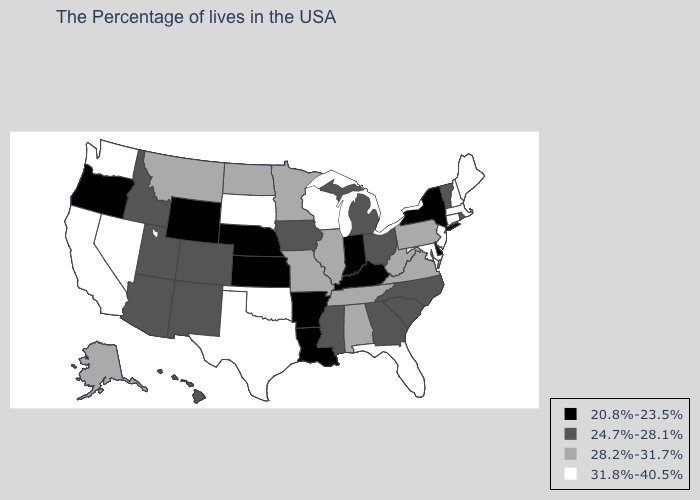Name the states that have a value in the range 31.8%-40.5%?
Short answer required. Maine, Massachusetts, New Hampshire, Connecticut, New Jersey, Maryland, Florida, Wisconsin, Oklahoma, Texas, South Dakota, Nevada, California, Washington. What is the value of West Virginia?
Quick response, please. 28.2%-31.7%. Name the states that have a value in the range 28.2%-31.7%?
Concise answer only. Pennsylvania, Virginia, West Virginia, Alabama, Tennessee, Illinois, Missouri, Minnesota, North Dakota, Montana, Alaska. What is the highest value in the West ?
Concise answer only. 31.8%-40.5%. Does the first symbol in the legend represent the smallest category?
Give a very brief answer. Yes. Which states hav the highest value in the MidWest?
Concise answer only. Wisconsin, South Dakota. Among the states that border Vermont , which have the highest value?
Give a very brief answer. Massachusetts, New Hampshire. What is the highest value in the USA?
Give a very brief answer. 31.8%-40.5%. Name the states that have a value in the range 24.7%-28.1%?
Write a very short answer. Rhode Island, Vermont, North Carolina, South Carolina, Ohio, Georgia, Michigan, Mississippi, Iowa, Colorado, New Mexico, Utah, Arizona, Idaho, Hawaii. Among the states that border Tennessee , which have the lowest value?
Be succinct. Kentucky, Arkansas. What is the value of Montana?
Give a very brief answer. 28.2%-31.7%. What is the lowest value in states that border Wisconsin?
Answer briefly. 24.7%-28.1%. Does Connecticut have the same value as Indiana?
Write a very short answer. No. What is the highest value in states that border Iowa?
Concise answer only. 31.8%-40.5%. What is the value of Rhode Island?
Be succinct. 24.7%-28.1%. 